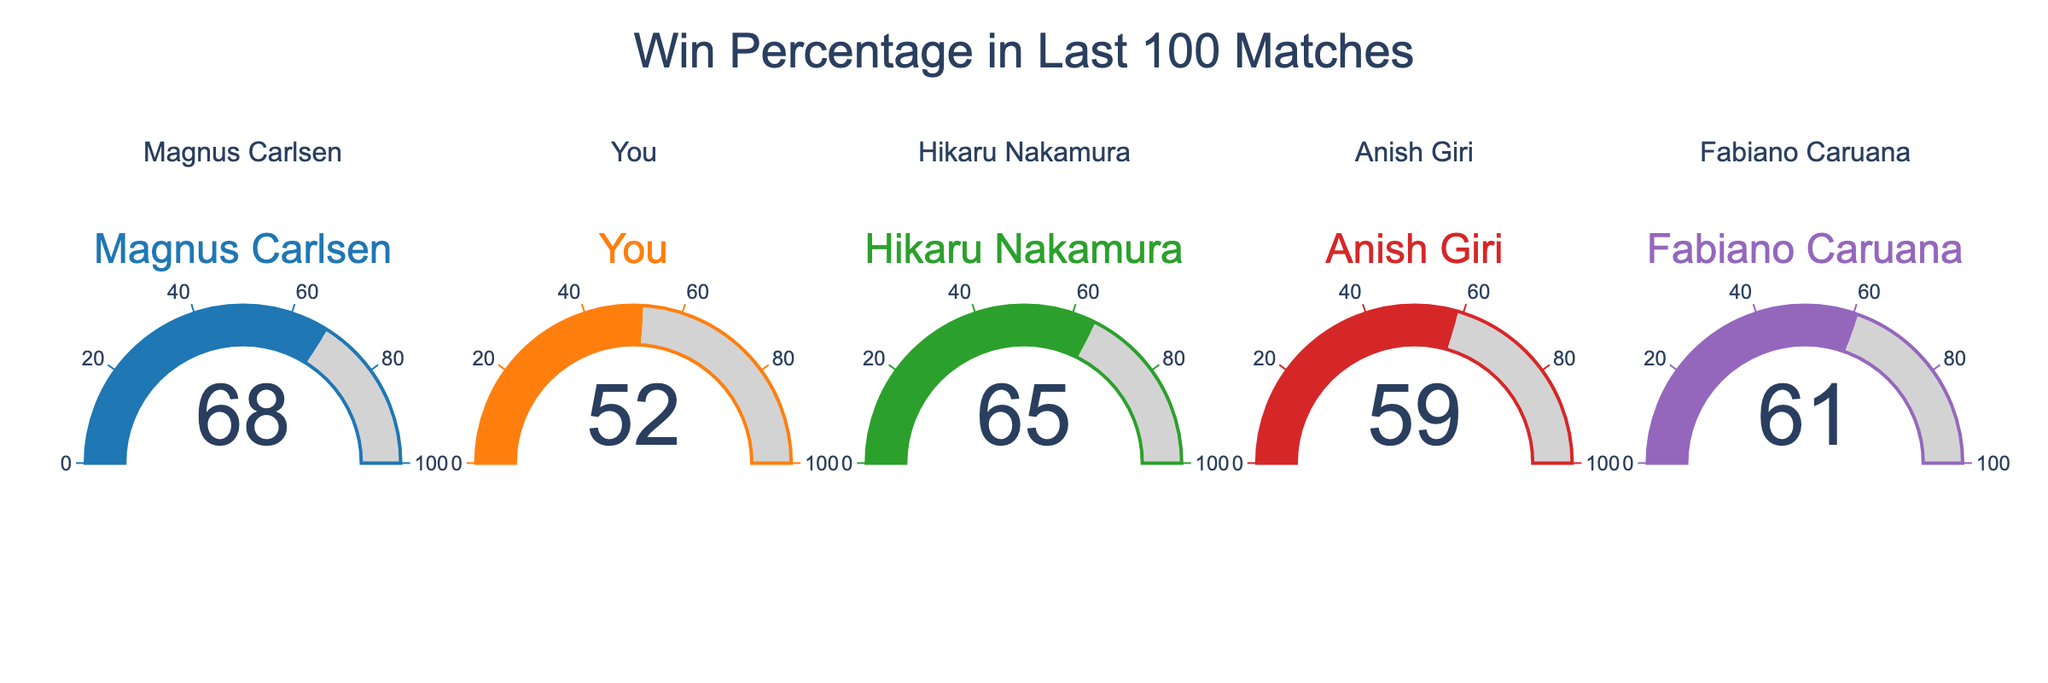What's the title of the figure? The title is located at the top center of the figure. It should clearly indicate what the figure represents.
Answer: Win Percentage in Last 100 Matches How many players' win percentages are displayed in the figure? The figure has five separate gauges, each representing a different player's win percentage.
Answer: 5 Which player has the highest win percentage? By examining the values displayed on the gauges, we can see which player has the highest number.
Answer: Magnus Carlsen What is the difference between your win percentage and Hikaru Nakamura's? To find this, subtract the smaller value (your win percentage) from the larger value (Hikaru Nakamura's win percentage). 65 - 52 = 13
Answer: 13 How does Anish Giri's win percentage compare to Fabiano Caruana's? Compare the values on their respective gauges to see who has the higher number. 59 (Anish Giri) is less than 61 (Fabiano Caruana)
Answer: Anish Giri's is less What's the average win percentage of all the players? Add up all the win percentages and divide by the number of players: (68 + 52 + 65 + 59 + 61) / 5
Answer: 61 Which player’s gauge has the darkest color? By observing the colors associated with each gauge, we can determine which one has the most saturated/darkest color. Typically, colors like blue or red tend to be darker.
Answer: Magnus Carlsen Is there any player with a win percentage lower than 55? Look at the values on each gauge. If any value is less than 55, the answer is yes. You have a win percentage of 52, which is less than 55.
Answer: Yes Among the displayed players, is your win percentage closer to Anish Giri's or Hikaru Nakamura's? Calculate the absolute difference between your win percentage and each of the other two players:
Answer: Anish Giri What is the combined win percentage of Magnus Carlsen and Hikaru Nakamura? Simply add the win percentages of Magnus Carlsen and Hikaru Nakamura: 68 + 65 = 133
Answer: 133 